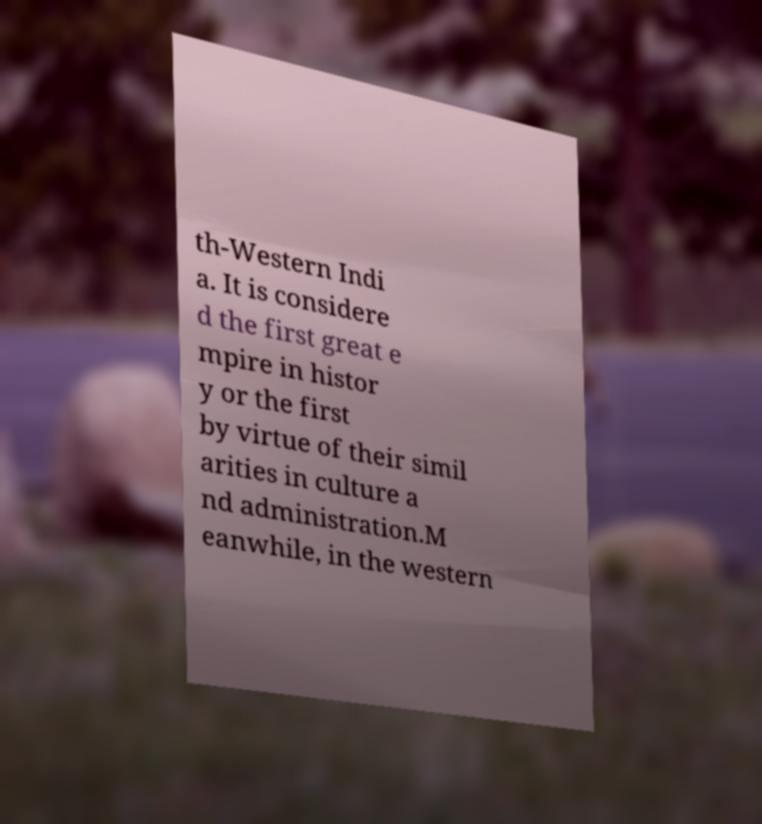Please read and relay the text visible in this image. What does it say? th-Western Indi a. It is considere d the first great e mpire in histor y or the first by virtue of their simil arities in culture a nd administration.M eanwhile, in the western 